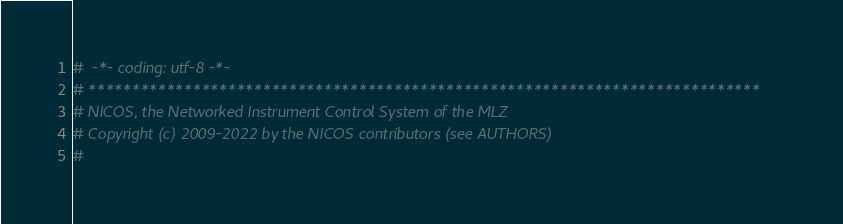<code> <loc_0><loc_0><loc_500><loc_500><_Python_>#  -*- coding: utf-8 -*-
# *****************************************************************************
# NICOS, the Networked Instrument Control System of the MLZ
# Copyright (c) 2009-2022 by the NICOS contributors (see AUTHORS)
#</code> 